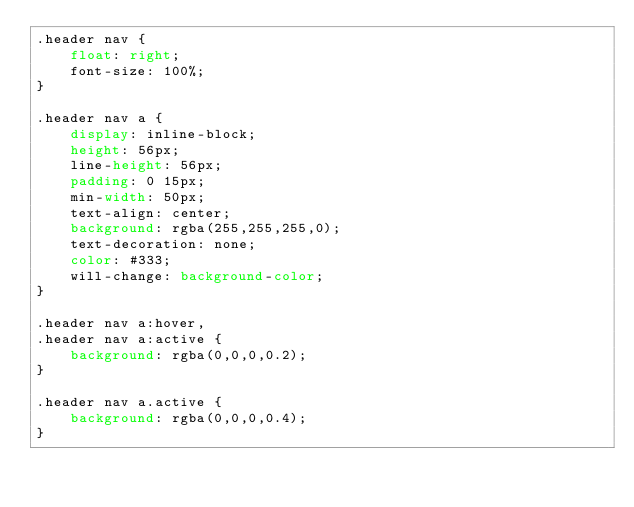<code> <loc_0><loc_0><loc_500><loc_500><_CSS_>.header nav {
	float: right;
	font-size: 100%;
}

.header nav a {
	display: inline-block;
	height: 56px;
	line-height: 56px;
	padding: 0 15px;
	min-width: 50px;
	text-align: center;
	background: rgba(255,255,255,0);
	text-decoration: none;
	color: #333;
	will-change: background-color;
}

.header nav a:hover,
.header nav a:active {
	background: rgba(0,0,0,0.2);
}

.header nav a.active {
	background: rgba(0,0,0,0.4);
}
</code> 